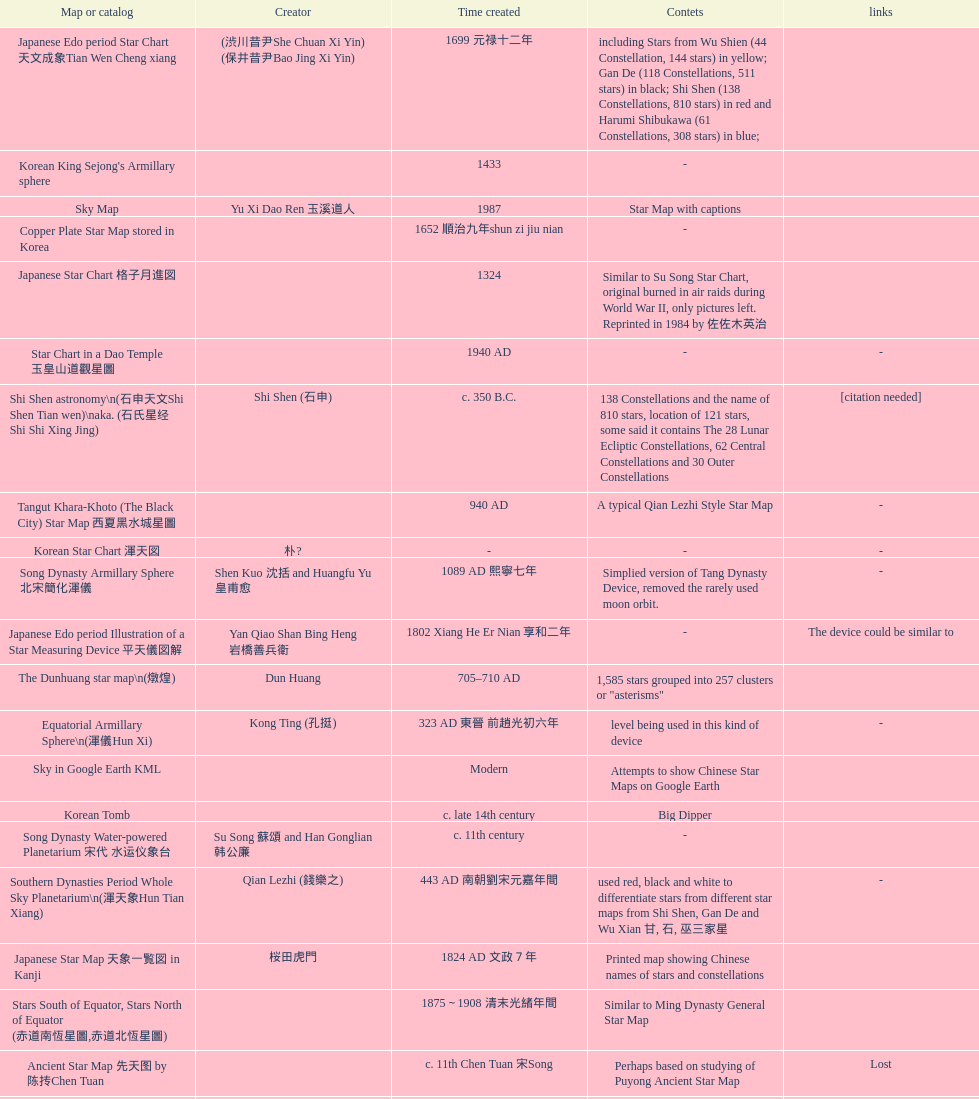Which map or catalog was created last? Sky in Google Earth KML. 